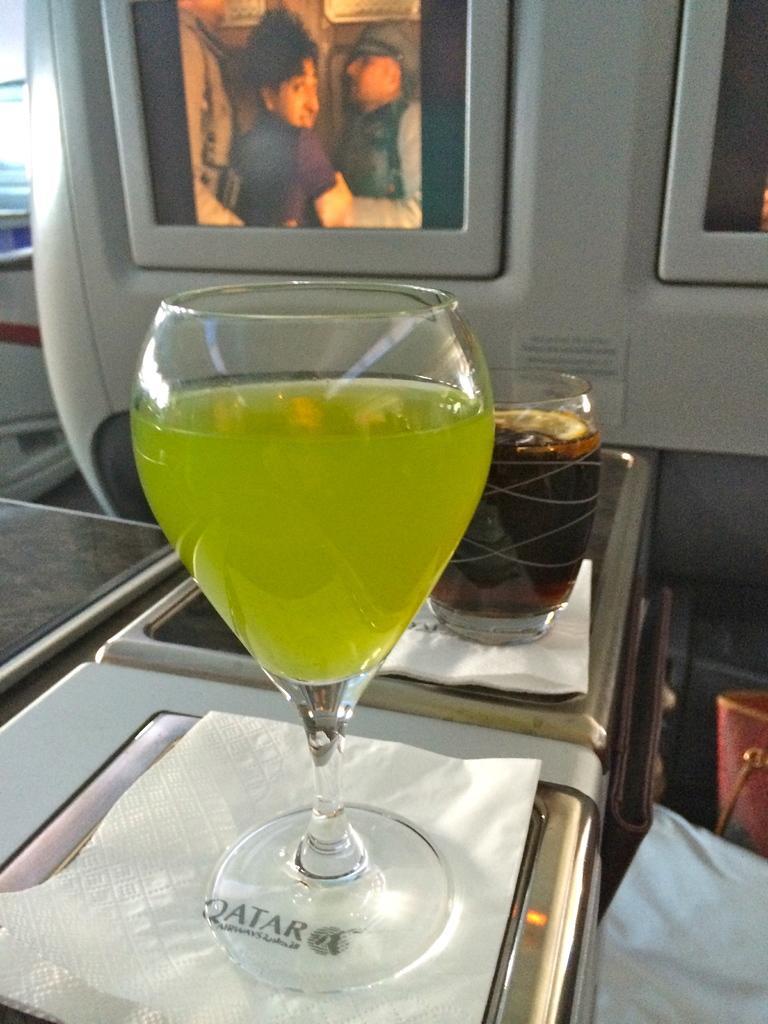In one or two sentences, can you explain what this image depicts? In this image we can see glasses with liquids on the tissues. In the background of the image there are screens. On the right side of the image there are some objects. 